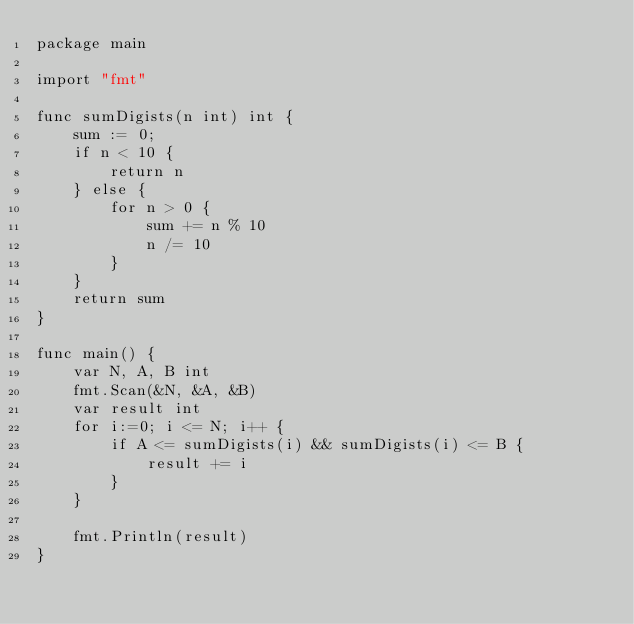<code> <loc_0><loc_0><loc_500><loc_500><_Go_>package main

import "fmt"

func sumDigists(n int) int {
	sum := 0;
	if n < 10 {
		return n
	} else {
		for n > 0 {
			sum += n % 10
			n /= 10
		}
	}
	return sum
}

func main() {
	var N, A, B int
	fmt.Scan(&N, &A, &B)
	var result int
	for i:=0; i <= N; i++ {
		if A <= sumDigists(i) && sumDigists(i) <= B {
			result += i
		}
	}

	fmt.Println(result)
}</code> 